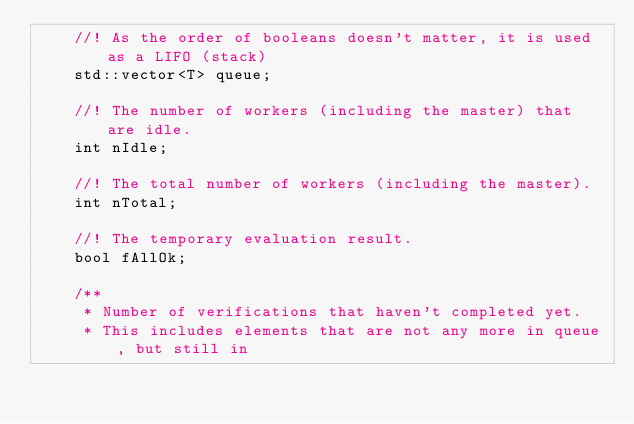<code> <loc_0><loc_0><loc_500><loc_500><_C_>    //! As the order of booleans doesn't matter, it is used as a LIFO (stack)
    std::vector<T> queue;

    //! The number of workers (including the master) that are idle.
    int nIdle;

    //! The total number of workers (including the master).
    int nTotal;

    //! The temporary evaluation result.
    bool fAllOk;

    /**
     * Number of verifications that haven't completed yet.
     * This includes elements that are not any more in queue, but still in</code> 